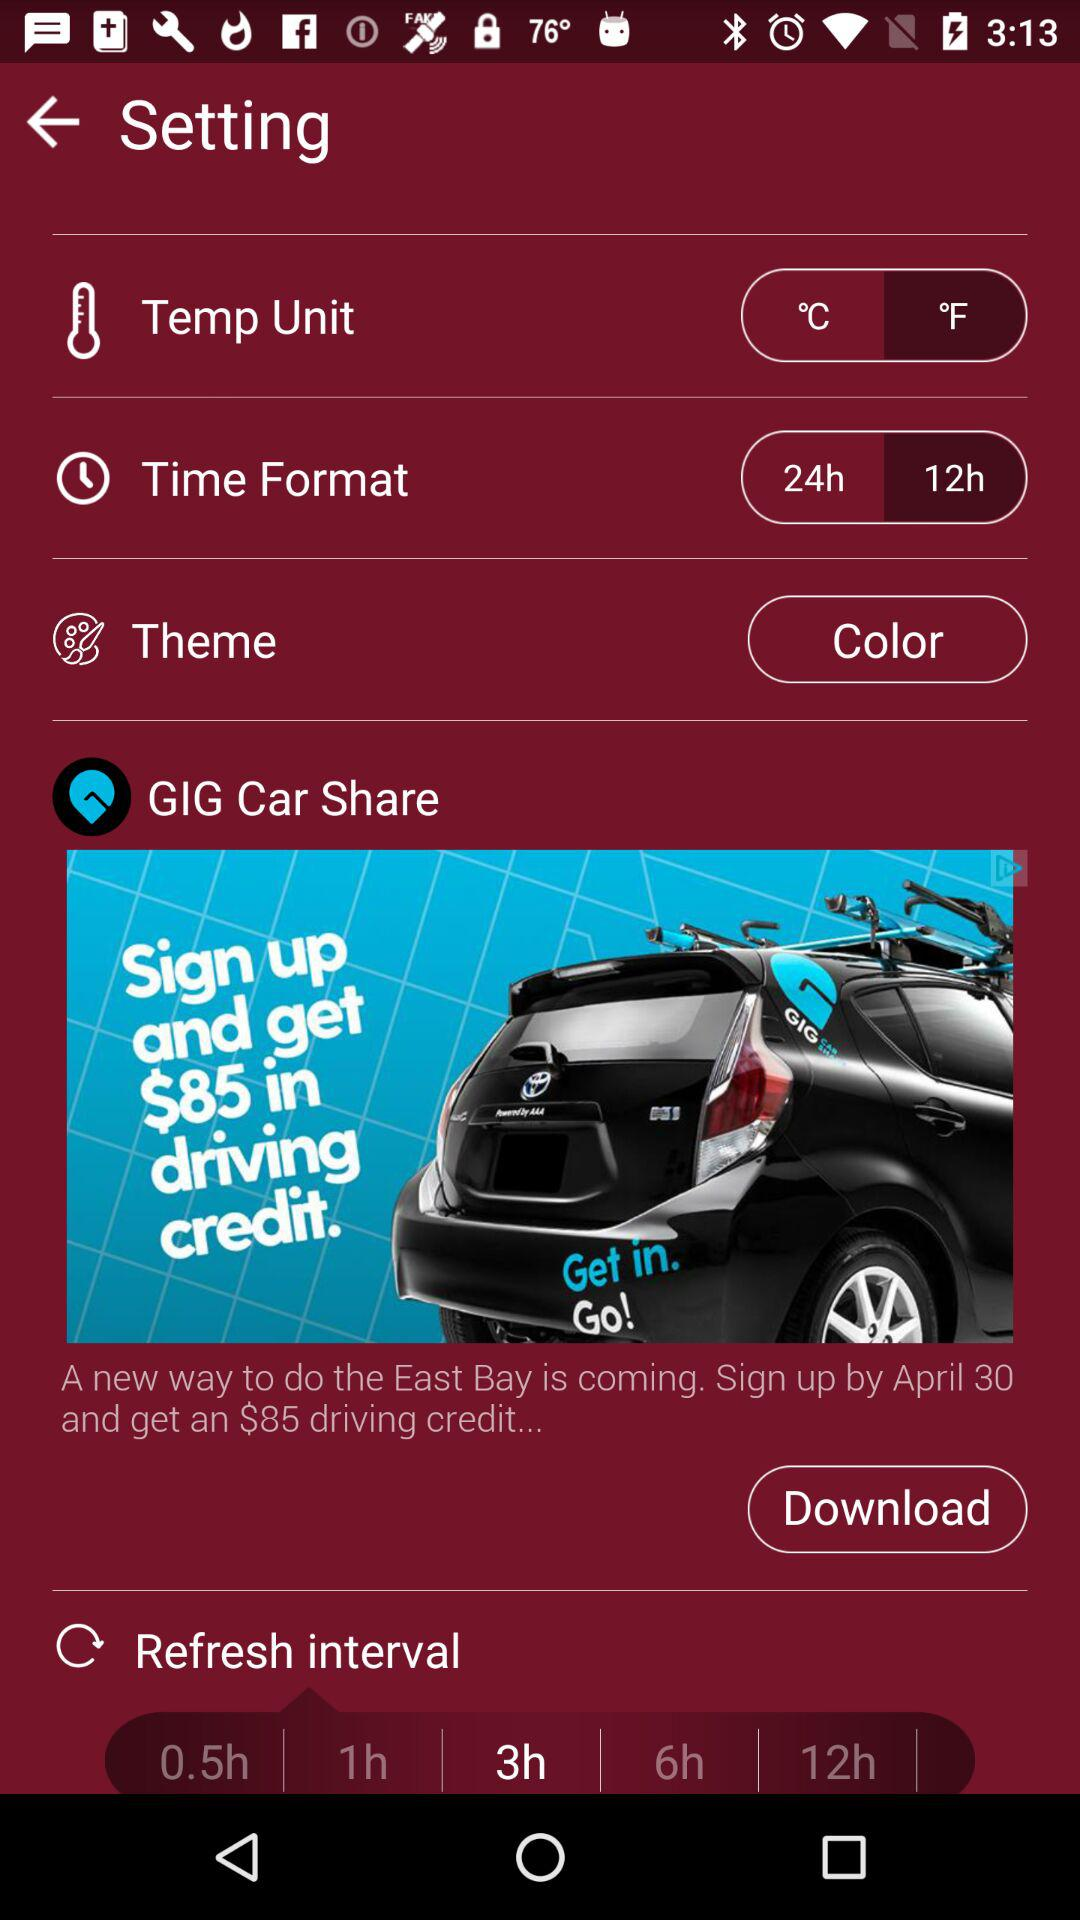What is the selected time format? The selected time format is "12h". 